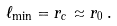Convert formula to latex. <formula><loc_0><loc_0><loc_500><loc_500>\ell _ { \min } = r _ { c } \approx r _ { 0 } \, .</formula> 